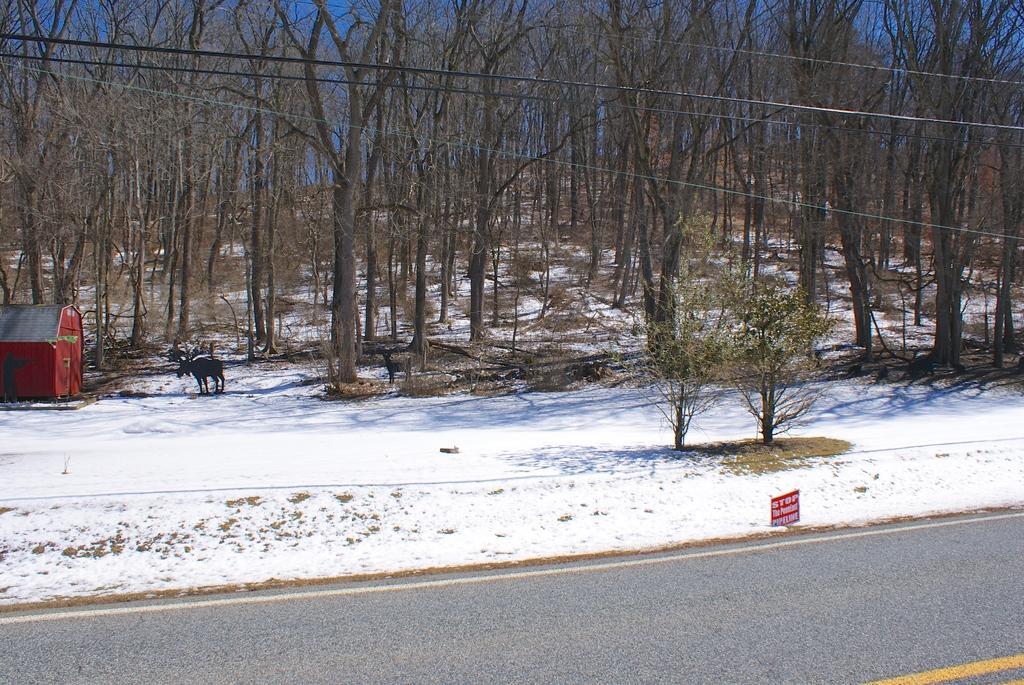How would you summarize this image in a sentence or two? In the center of the image there are trees. At the bottom we can see a road and snow. On the left there is an animal and a shed. At the top we can see wires. 